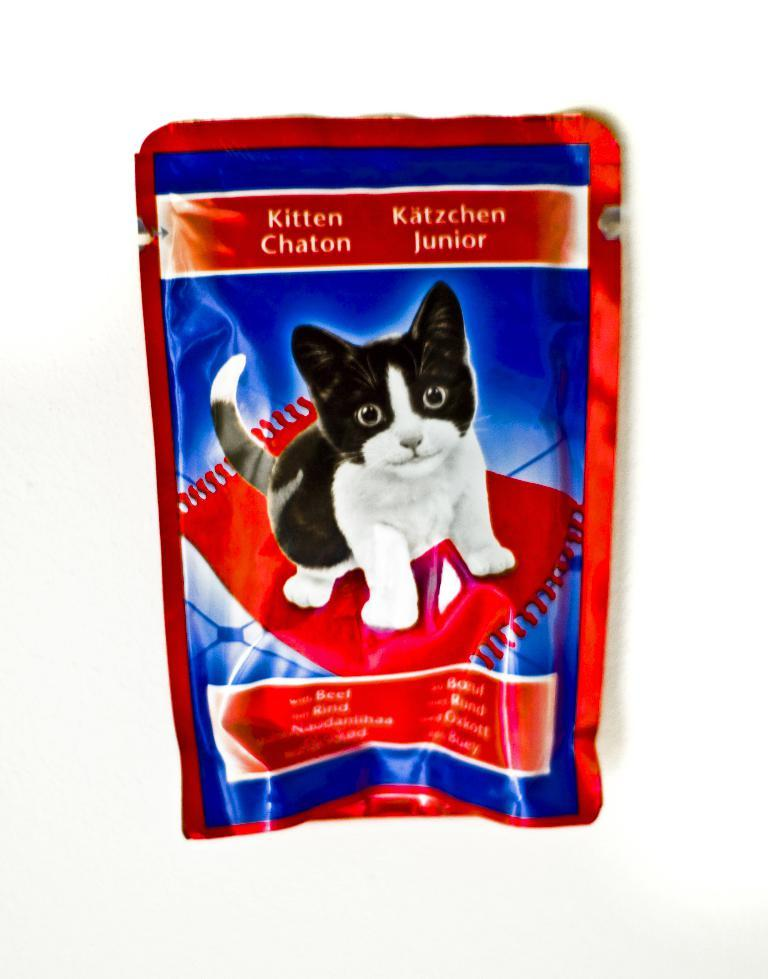What is the main object in the image? There is a packet in the image. What colors are present on the packet? The packet has red and blue colors. What image can be seen on the packet? There is an image of a cat on the red part of the packet. What is the background color of the carpet in the image? The packet is on a red color carpet. What can be found on the packet besides the image? There is some text visible on the packet. Can you see a tiger running along the coast in the image? There is no tiger or coast visible in the image; it features a packet with a cat image and text. 